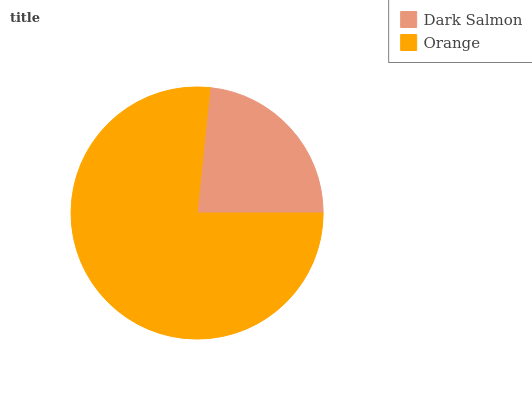Is Dark Salmon the minimum?
Answer yes or no. Yes. Is Orange the maximum?
Answer yes or no. Yes. Is Orange the minimum?
Answer yes or no. No. Is Orange greater than Dark Salmon?
Answer yes or no. Yes. Is Dark Salmon less than Orange?
Answer yes or no. Yes. Is Dark Salmon greater than Orange?
Answer yes or no. No. Is Orange less than Dark Salmon?
Answer yes or no. No. Is Orange the high median?
Answer yes or no. Yes. Is Dark Salmon the low median?
Answer yes or no. Yes. Is Dark Salmon the high median?
Answer yes or no. No. Is Orange the low median?
Answer yes or no. No. 